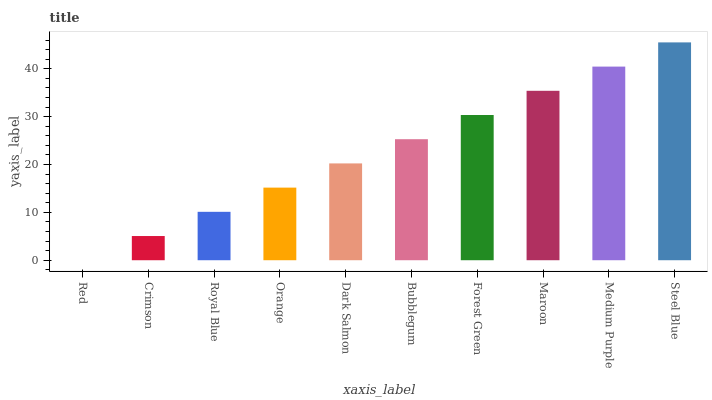Is Crimson the minimum?
Answer yes or no. No. Is Crimson the maximum?
Answer yes or no. No. Is Crimson greater than Red?
Answer yes or no. Yes. Is Red less than Crimson?
Answer yes or no. Yes. Is Red greater than Crimson?
Answer yes or no. No. Is Crimson less than Red?
Answer yes or no. No. Is Bubblegum the high median?
Answer yes or no. Yes. Is Dark Salmon the low median?
Answer yes or no. Yes. Is Forest Green the high median?
Answer yes or no. No. Is Orange the low median?
Answer yes or no. No. 